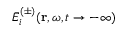Convert formula to latex. <formula><loc_0><loc_0><loc_500><loc_500>\bar { E } _ { i } ^ { ( \pm ) } ( r , \omega , t \rightarrow - \infty )</formula> 